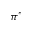Convert formula to latex. <formula><loc_0><loc_0><loc_500><loc_500>\pi ^ { * }</formula> 